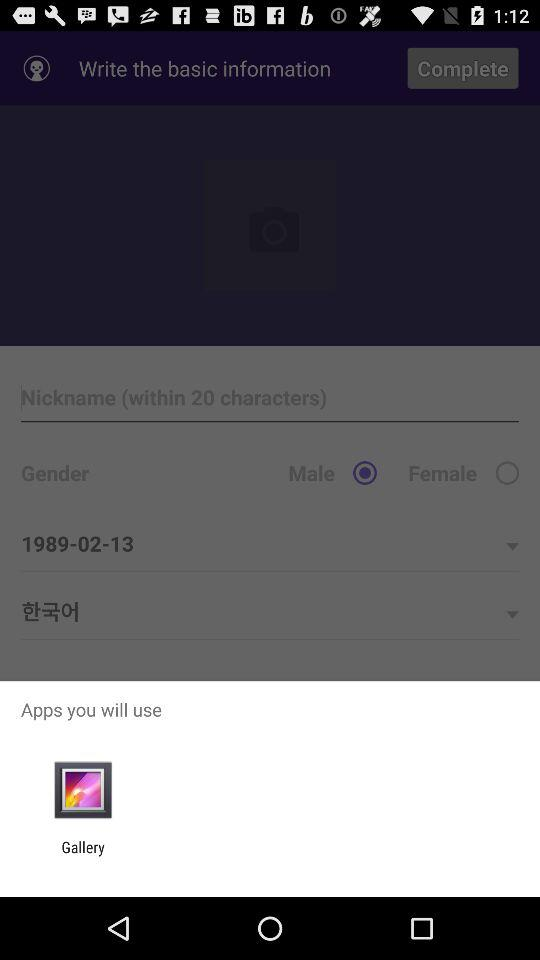What is the date? The date is February 13, 1989. 